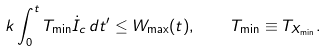Convert formula to latex. <formula><loc_0><loc_0><loc_500><loc_500>k \int _ { 0 } ^ { t } T _ { \min } \dot { I } _ { c } \, d t ^ { \prime } \leq W _ { \max } ( t ) , \quad T _ { \min } \equiv T _ { X _ { \min } } .</formula> 